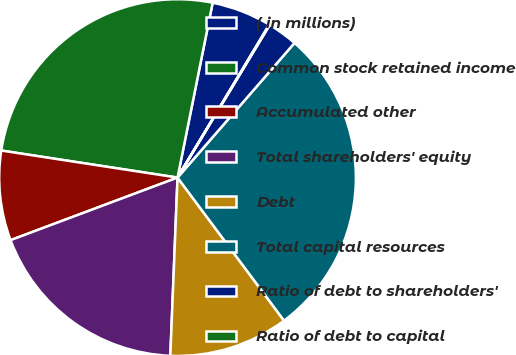<chart> <loc_0><loc_0><loc_500><loc_500><pie_chart><fcel>( in millions)<fcel>Common stock retained income<fcel>Accumulated other<fcel>Total shareholders' equity<fcel>Debt<fcel>Total capital resources<fcel>Ratio of debt to shareholders'<fcel>Ratio of debt to capital<nl><fcel>5.44%<fcel>25.73%<fcel>8.13%<fcel>18.65%<fcel>10.83%<fcel>28.43%<fcel>2.74%<fcel>0.05%<nl></chart> 